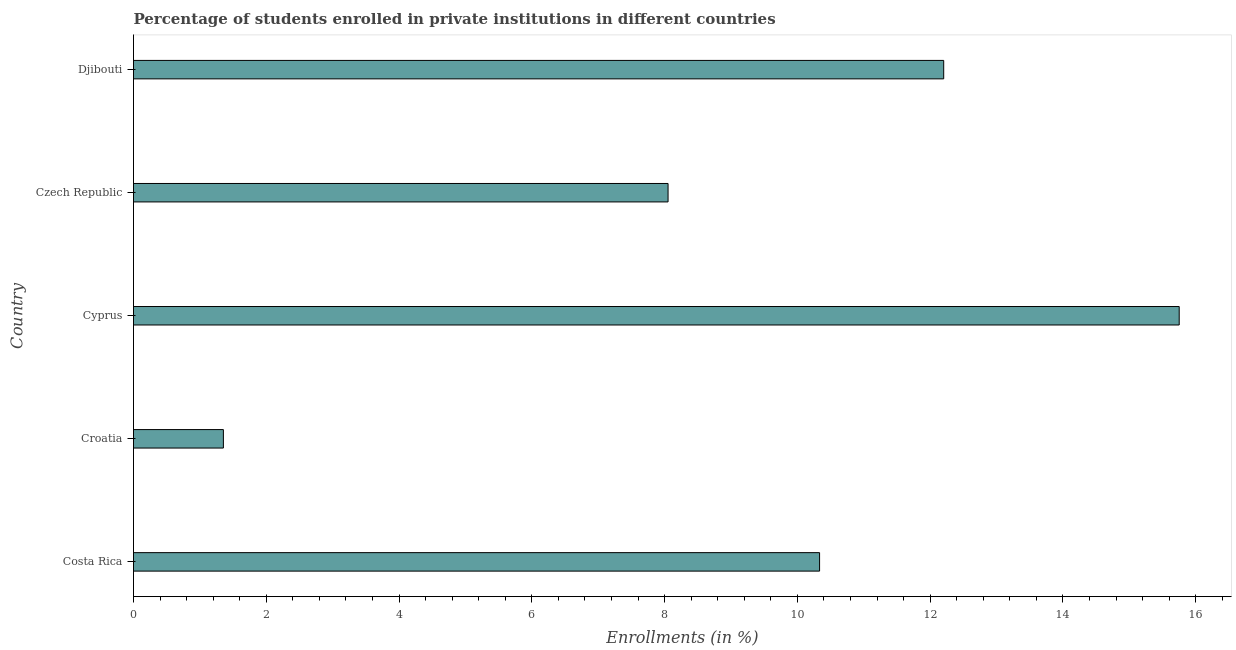Does the graph contain grids?
Offer a terse response. No. What is the title of the graph?
Give a very brief answer. Percentage of students enrolled in private institutions in different countries. What is the label or title of the X-axis?
Offer a terse response. Enrollments (in %). What is the enrollments in private institutions in Costa Rica?
Provide a short and direct response. 10.33. Across all countries, what is the maximum enrollments in private institutions?
Provide a succinct answer. 15.75. Across all countries, what is the minimum enrollments in private institutions?
Offer a terse response. 1.35. In which country was the enrollments in private institutions maximum?
Provide a short and direct response. Cyprus. In which country was the enrollments in private institutions minimum?
Provide a succinct answer. Croatia. What is the sum of the enrollments in private institutions?
Your answer should be compact. 47.7. What is the difference between the enrollments in private institutions in Costa Rica and Croatia?
Offer a very short reply. 8.98. What is the average enrollments in private institutions per country?
Provide a succinct answer. 9.54. What is the median enrollments in private institutions?
Your response must be concise. 10.33. In how many countries, is the enrollments in private institutions greater than 4.4 %?
Offer a terse response. 4. What is the ratio of the enrollments in private institutions in Costa Rica to that in Czech Republic?
Ensure brevity in your answer.  1.28. Is the enrollments in private institutions in Cyprus less than that in Djibouti?
Give a very brief answer. No. Is the difference between the enrollments in private institutions in Costa Rica and Cyprus greater than the difference between any two countries?
Offer a terse response. No. What is the difference between the highest and the second highest enrollments in private institutions?
Make the answer very short. 3.55. Is the sum of the enrollments in private institutions in Croatia and Djibouti greater than the maximum enrollments in private institutions across all countries?
Your answer should be very brief. No. In how many countries, is the enrollments in private institutions greater than the average enrollments in private institutions taken over all countries?
Your response must be concise. 3. How many bars are there?
Your answer should be compact. 5. What is the difference between two consecutive major ticks on the X-axis?
Provide a short and direct response. 2. Are the values on the major ticks of X-axis written in scientific E-notation?
Make the answer very short. No. What is the Enrollments (in %) in Costa Rica?
Your answer should be compact. 10.33. What is the Enrollments (in %) in Croatia?
Give a very brief answer. 1.35. What is the Enrollments (in %) in Cyprus?
Provide a short and direct response. 15.75. What is the Enrollments (in %) in Czech Republic?
Offer a terse response. 8.05. What is the Enrollments (in %) of Djibouti?
Provide a succinct answer. 12.2. What is the difference between the Enrollments (in %) in Costa Rica and Croatia?
Offer a very short reply. 8.98. What is the difference between the Enrollments (in %) in Costa Rica and Cyprus?
Keep it short and to the point. -5.42. What is the difference between the Enrollments (in %) in Costa Rica and Czech Republic?
Your answer should be compact. 2.28. What is the difference between the Enrollments (in %) in Costa Rica and Djibouti?
Your response must be concise. -1.87. What is the difference between the Enrollments (in %) in Croatia and Cyprus?
Ensure brevity in your answer.  -14.4. What is the difference between the Enrollments (in %) in Croatia and Czech Republic?
Give a very brief answer. -6.7. What is the difference between the Enrollments (in %) in Croatia and Djibouti?
Provide a succinct answer. -10.85. What is the difference between the Enrollments (in %) in Cyprus and Czech Republic?
Your answer should be very brief. 7.7. What is the difference between the Enrollments (in %) in Cyprus and Djibouti?
Give a very brief answer. 3.55. What is the difference between the Enrollments (in %) in Czech Republic and Djibouti?
Offer a very short reply. -4.15. What is the ratio of the Enrollments (in %) in Costa Rica to that in Croatia?
Ensure brevity in your answer.  7.63. What is the ratio of the Enrollments (in %) in Costa Rica to that in Cyprus?
Make the answer very short. 0.66. What is the ratio of the Enrollments (in %) in Costa Rica to that in Czech Republic?
Keep it short and to the point. 1.28. What is the ratio of the Enrollments (in %) in Costa Rica to that in Djibouti?
Make the answer very short. 0.85. What is the ratio of the Enrollments (in %) in Croatia to that in Cyprus?
Your answer should be compact. 0.09. What is the ratio of the Enrollments (in %) in Croatia to that in Czech Republic?
Your response must be concise. 0.17. What is the ratio of the Enrollments (in %) in Croatia to that in Djibouti?
Provide a succinct answer. 0.11. What is the ratio of the Enrollments (in %) in Cyprus to that in Czech Republic?
Your answer should be very brief. 1.96. What is the ratio of the Enrollments (in %) in Cyprus to that in Djibouti?
Provide a short and direct response. 1.29. What is the ratio of the Enrollments (in %) in Czech Republic to that in Djibouti?
Your answer should be very brief. 0.66. 